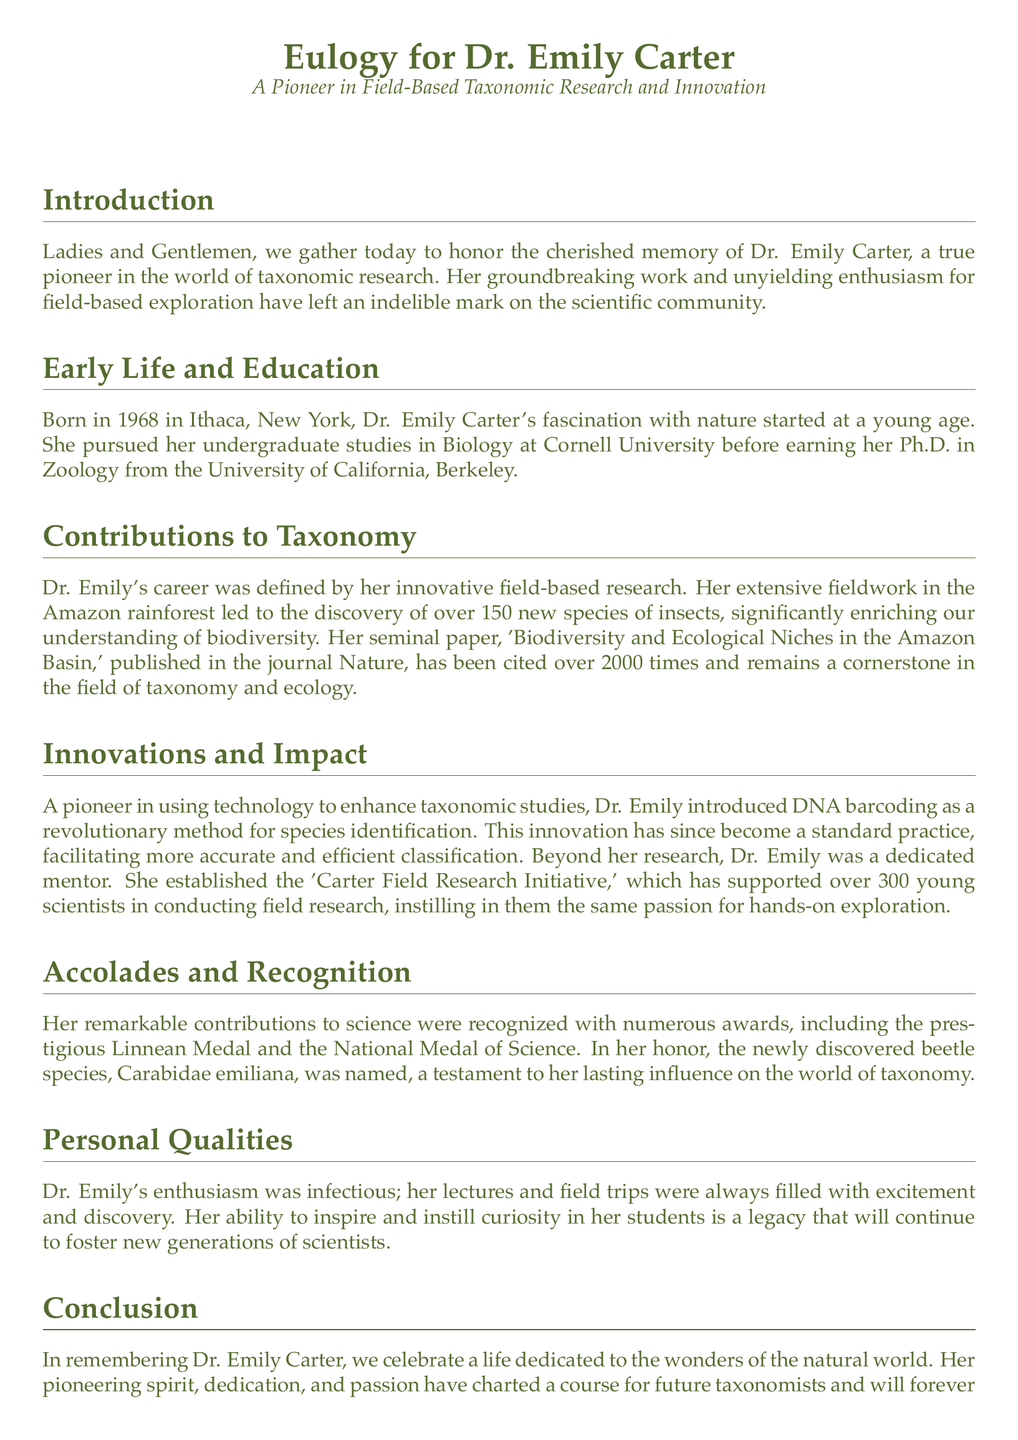What year was Dr. Emily born? The document states that Dr. Emily was born in 1968.
Answer: 1968 What university did Dr. Emily attend for her Ph.D.? According to the document, she earned her Ph.D. from the University of California, Berkeley.
Answer: University of California, Berkeley How many new species of insects did Dr. Emily discover? The eulogy mentions that she discovered over 150 new species of insects.
Answer: over 150 What innovative method for species identification did Dr. Emily introduce? The document describes that she introduced DNA barcoding as a revolutionary method.
Answer: DNA barcoding How many young scientists have benefited from the 'Carter Field Research Initiative'? The eulogy states that the initiative has supported over 300 young scientists.
Answer: over 300 What prestigious award did Dr. Emily receive? The document lists the Linnean Medal as one of her numerous awards.
Answer: Linnean Medal Why is Carabidae emiliana significant? According to the eulogy, Carabidae emiliana was named in her honor, reflecting her lasting influence.
Answer: named in her honor What impact did Dr. Emily have on her students? The document describes her ability to inspire and instill curiosity in her students.
Answer: inspired and instilled curiosity What is the purpose of a eulogy? The eulogy serves to honor and remember the contributions and legacy of Dr. Emily.
Answer: honor and remember 